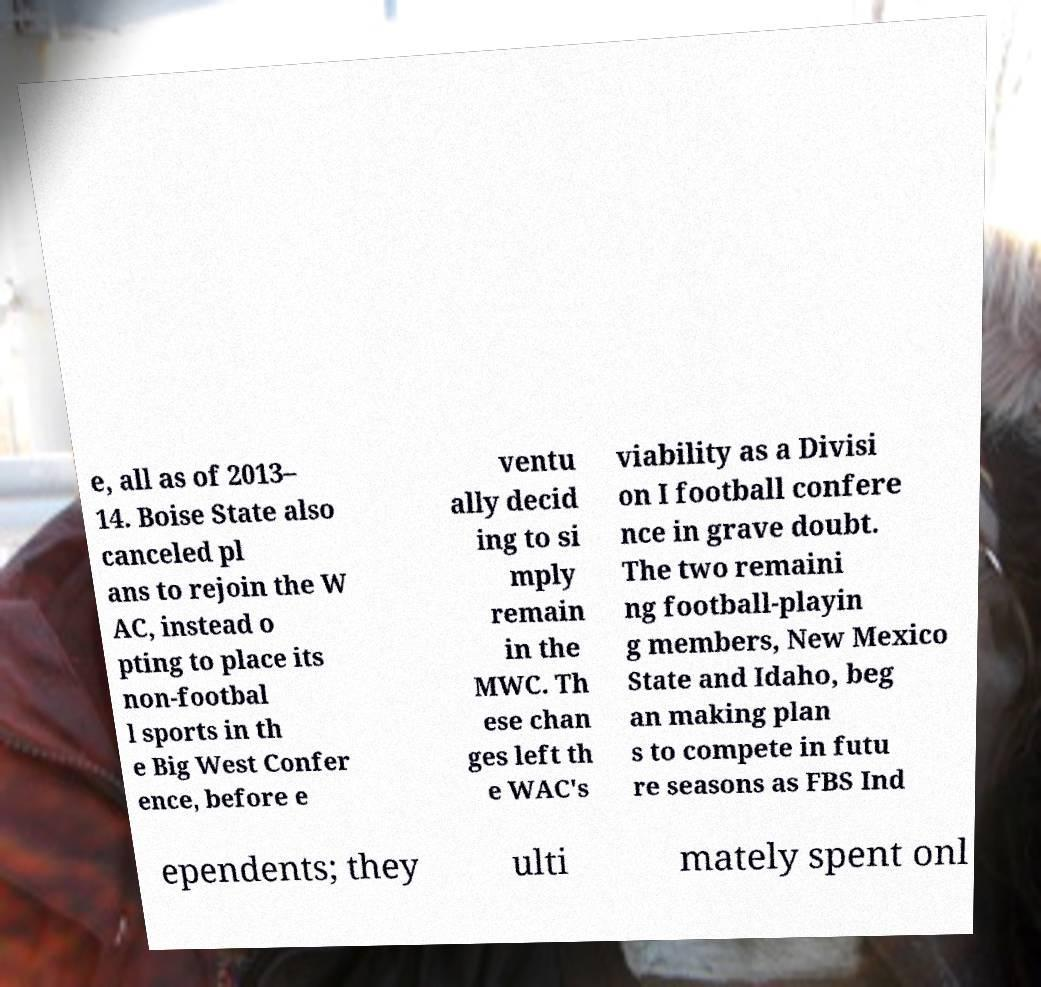There's text embedded in this image that I need extracted. Can you transcribe it verbatim? e, all as of 2013– 14. Boise State also canceled pl ans to rejoin the W AC, instead o pting to place its non-footbal l sports in th e Big West Confer ence, before e ventu ally decid ing to si mply remain in the MWC. Th ese chan ges left th e WAC's viability as a Divisi on I football confere nce in grave doubt. The two remaini ng football-playin g members, New Mexico State and Idaho, beg an making plan s to compete in futu re seasons as FBS Ind ependents; they ulti mately spent onl 